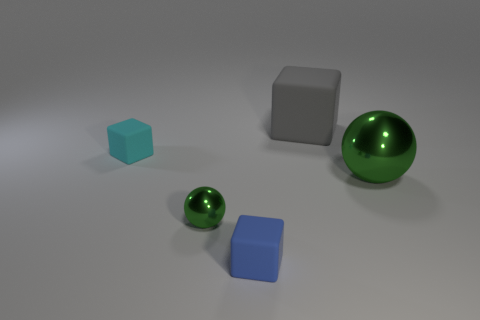Subtract all small cyan rubber cubes. How many cubes are left? 2 Subtract all cyan cubes. How many cubes are left? 2 Subtract 2 blocks. How many blocks are left? 1 Subtract all brown spheres. How many gray blocks are left? 1 Add 1 gray matte objects. How many objects exist? 6 Subtract all spheres. How many objects are left? 3 Subtract 0 red spheres. How many objects are left? 5 Subtract all red blocks. Subtract all green balls. How many blocks are left? 3 Subtract all green cylinders. Subtract all big gray cubes. How many objects are left? 4 Add 1 blue rubber blocks. How many blue rubber blocks are left? 2 